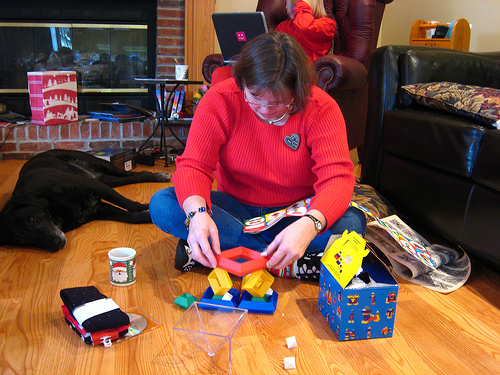<image>
Is the dog on the floor? Yes. Looking at the image, I can see the dog is positioned on top of the floor, with the floor providing support. Is there a wooden table above the cloths? No. The wooden table is not positioned above the cloths. The vertical arrangement shows a different relationship. 